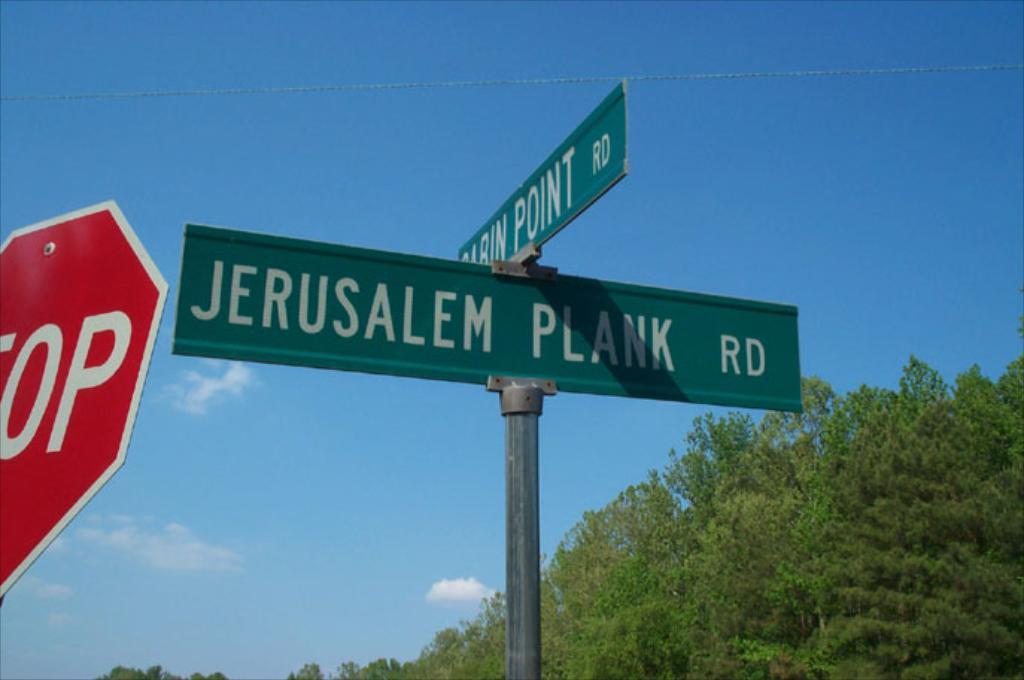Provide a one-sentence caption for the provided image. A street sign next to a stop sign or Jerusalem Plank Road. 